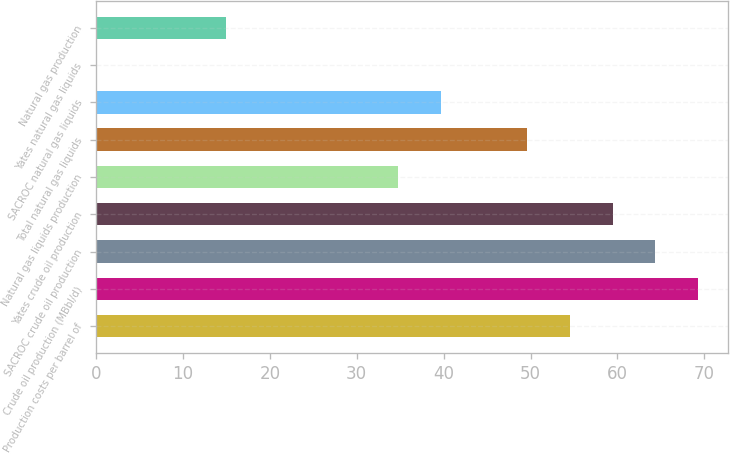<chart> <loc_0><loc_0><loc_500><loc_500><bar_chart><fcel>Production costs per barrel of<fcel>Crude oil production (MBbl/d)<fcel>SACROC crude oil production<fcel>Yates crude oil production<fcel>Natural gas liquids production<fcel>Total natural gas liquids<fcel>SACROC natural gas liquids<fcel>Yates natural gas liquids<fcel>Natural gas production<nl><fcel>54.49<fcel>69.32<fcel>64.38<fcel>59.44<fcel>34.72<fcel>49.55<fcel>39.66<fcel>0.1<fcel>14.93<nl></chart> 